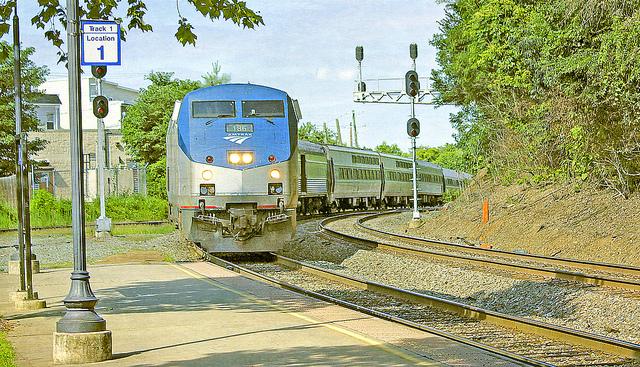What color is the front of the train?
Give a very brief answer. Blue. Are there wires shown?
Short answer required. No. What number is shown on the lamp post?
Keep it brief. 1. Is it raining in this photo?
Keep it brief. No. 